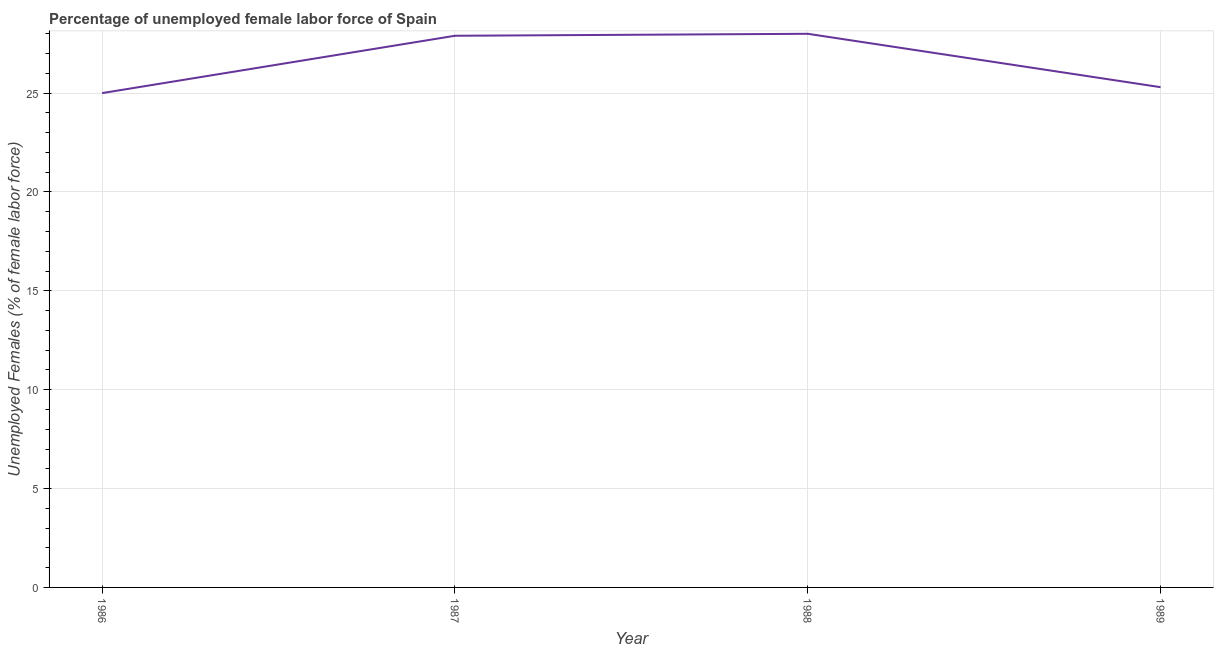What is the total unemployed female labour force in 1986?
Give a very brief answer. 25. Across all years, what is the maximum total unemployed female labour force?
Provide a succinct answer. 28. In which year was the total unemployed female labour force minimum?
Provide a succinct answer. 1986. What is the sum of the total unemployed female labour force?
Ensure brevity in your answer.  106.2. What is the difference between the total unemployed female labour force in 1986 and 1989?
Provide a succinct answer. -0.3. What is the average total unemployed female labour force per year?
Your answer should be compact. 26.55. What is the median total unemployed female labour force?
Offer a very short reply. 26.6. What is the ratio of the total unemployed female labour force in 1988 to that in 1989?
Make the answer very short. 1.11. What is the difference between the highest and the second highest total unemployed female labour force?
Make the answer very short. 0.1. In how many years, is the total unemployed female labour force greater than the average total unemployed female labour force taken over all years?
Ensure brevity in your answer.  2. Does the total unemployed female labour force monotonically increase over the years?
Your answer should be very brief. No. What is the difference between two consecutive major ticks on the Y-axis?
Provide a short and direct response. 5. What is the title of the graph?
Make the answer very short. Percentage of unemployed female labor force of Spain. What is the label or title of the Y-axis?
Your response must be concise. Unemployed Females (% of female labor force). What is the Unemployed Females (% of female labor force) of 1986?
Provide a short and direct response. 25. What is the Unemployed Females (% of female labor force) of 1987?
Provide a short and direct response. 27.9. What is the Unemployed Females (% of female labor force) in 1989?
Keep it short and to the point. 25.3. What is the difference between the Unemployed Females (% of female labor force) in 1987 and 1988?
Provide a short and direct response. -0.1. What is the difference between the Unemployed Females (% of female labor force) in 1987 and 1989?
Your answer should be compact. 2.6. What is the ratio of the Unemployed Females (% of female labor force) in 1986 to that in 1987?
Keep it short and to the point. 0.9. What is the ratio of the Unemployed Females (% of female labor force) in 1986 to that in 1988?
Your response must be concise. 0.89. What is the ratio of the Unemployed Females (% of female labor force) in 1987 to that in 1988?
Offer a terse response. 1. What is the ratio of the Unemployed Females (% of female labor force) in 1987 to that in 1989?
Your answer should be very brief. 1.1. What is the ratio of the Unemployed Females (% of female labor force) in 1988 to that in 1989?
Offer a terse response. 1.11. 